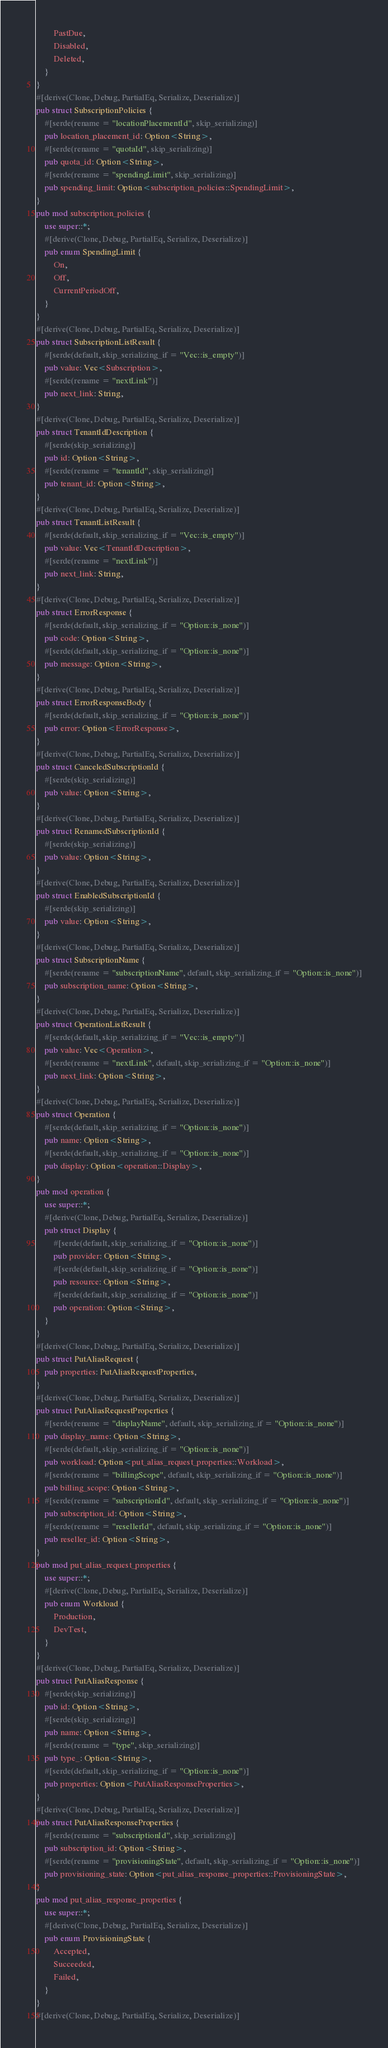<code> <loc_0><loc_0><loc_500><loc_500><_Rust_>        PastDue,
        Disabled,
        Deleted,
    }
}
#[derive(Clone, Debug, PartialEq, Serialize, Deserialize)]
pub struct SubscriptionPolicies {
    #[serde(rename = "locationPlacementId", skip_serializing)]
    pub location_placement_id: Option<String>,
    #[serde(rename = "quotaId", skip_serializing)]
    pub quota_id: Option<String>,
    #[serde(rename = "spendingLimit", skip_serializing)]
    pub spending_limit: Option<subscription_policies::SpendingLimit>,
}
pub mod subscription_policies {
    use super::*;
    #[derive(Clone, Debug, PartialEq, Serialize, Deserialize)]
    pub enum SpendingLimit {
        On,
        Off,
        CurrentPeriodOff,
    }
}
#[derive(Clone, Debug, PartialEq, Serialize, Deserialize)]
pub struct SubscriptionListResult {
    #[serde(default, skip_serializing_if = "Vec::is_empty")]
    pub value: Vec<Subscription>,
    #[serde(rename = "nextLink")]
    pub next_link: String,
}
#[derive(Clone, Debug, PartialEq, Serialize, Deserialize)]
pub struct TenantIdDescription {
    #[serde(skip_serializing)]
    pub id: Option<String>,
    #[serde(rename = "tenantId", skip_serializing)]
    pub tenant_id: Option<String>,
}
#[derive(Clone, Debug, PartialEq, Serialize, Deserialize)]
pub struct TenantListResult {
    #[serde(default, skip_serializing_if = "Vec::is_empty")]
    pub value: Vec<TenantIdDescription>,
    #[serde(rename = "nextLink")]
    pub next_link: String,
}
#[derive(Clone, Debug, PartialEq, Serialize, Deserialize)]
pub struct ErrorResponse {
    #[serde(default, skip_serializing_if = "Option::is_none")]
    pub code: Option<String>,
    #[serde(default, skip_serializing_if = "Option::is_none")]
    pub message: Option<String>,
}
#[derive(Clone, Debug, PartialEq, Serialize, Deserialize)]
pub struct ErrorResponseBody {
    #[serde(default, skip_serializing_if = "Option::is_none")]
    pub error: Option<ErrorResponse>,
}
#[derive(Clone, Debug, PartialEq, Serialize, Deserialize)]
pub struct CanceledSubscriptionId {
    #[serde(skip_serializing)]
    pub value: Option<String>,
}
#[derive(Clone, Debug, PartialEq, Serialize, Deserialize)]
pub struct RenamedSubscriptionId {
    #[serde(skip_serializing)]
    pub value: Option<String>,
}
#[derive(Clone, Debug, PartialEq, Serialize, Deserialize)]
pub struct EnabledSubscriptionId {
    #[serde(skip_serializing)]
    pub value: Option<String>,
}
#[derive(Clone, Debug, PartialEq, Serialize, Deserialize)]
pub struct SubscriptionName {
    #[serde(rename = "subscriptionName", default, skip_serializing_if = "Option::is_none")]
    pub subscription_name: Option<String>,
}
#[derive(Clone, Debug, PartialEq, Serialize, Deserialize)]
pub struct OperationListResult {
    #[serde(default, skip_serializing_if = "Vec::is_empty")]
    pub value: Vec<Operation>,
    #[serde(rename = "nextLink", default, skip_serializing_if = "Option::is_none")]
    pub next_link: Option<String>,
}
#[derive(Clone, Debug, PartialEq, Serialize, Deserialize)]
pub struct Operation {
    #[serde(default, skip_serializing_if = "Option::is_none")]
    pub name: Option<String>,
    #[serde(default, skip_serializing_if = "Option::is_none")]
    pub display: Option<operation::Display>,
}
pub mod operation {
    use super::*;
    #[derive(Clone, Debug, PartialEq, Serialize, Deserialize)]
    pub struct Display {
        #[serde(default, skip_serializing_if = "Option::is_none")]
        pub provider: Option<String>,
        #[serde(default, skip_serializing_if = "Option::is_none")]
        pub resource: Option<String>,
        #[serde(default, skip_serializing_if = "Option::is_none")]
        pub operation: Option<String>,
    }
}
#[derive(Clone, Debug, PartialEq, Serialize, Deserialize)]
pub struct PutAliasRequest {
    pub properties: PutAliasRequestProperties,
}
#[derive(Clone, Debug, PartialEq, Serialize, Deserialize)]
pub struct PutAliasRequestProperties {
    #[serde(rename = "displayName", default, skip_serializing_if = "Option::is_none")]
    pub display_name: Option<String>,
    #[serde(default, skip_serializing_if = "Option::is_none")]
    pub workload: Option<put_alias_request_properties::Workload>,
    #[serde(rename = "billingScope", default, skip_serializing_if = "Option::is_none")]
    pub billing_scope: Option<String>,
    #[serde(rename = "subscriptionId", default, skip_serializing_if = "Option::is_none")]
    pub subscription_id: Option<String>,
    #[serde(rename = "resellerId", default, skip_serializing_if = "Option::is_none")]
    pub reseller_id: Option<String>,
}
pub mod put_alias_request_properties {
    use super::*;
    #[derive(Clone, Debug, PartialEq, Serialize, Deserialize)]
    pub enum Workload {
        Production,
        DevTest,
    }
}
#[derive(Clone, Debug, PartialEq, Serialize, Deserialize)]
pub struct PutAliasResponse {
    #[serde(skip_serializing)]
    pub id: Option<String>,
    #[serde(skip_serializing)]
    pub name: Option<String>,
    #[serde(rename = "type", skip_serializing)]
    pub type_: Option<String>,
    #[serde(default, skip_serializing_if = "Option::is_none")]
    pub properties: Option<PutAliasResponseProperties>,
}
#[derive(Clone, Debug, PartialEq, Serialize, Deserialize)]
pub struct PutAliasResponseProperties {
    #[serde(rename = "subscriptionId", skip_serializing)]
    pub subscription_id: Option<String>,
    #[serde(rename = "provisioningState", default, skip_serializing_if = "Option::is_none")]
    pub provisioning_state: Option<put_alias_response_properties::ProvisioningState>,
}
pub mod put_alias_response_properties {
    use super::*;
    #[derive(Clone, Debug, PartialEq, Serialize, Deserialize)]
    pub enum ProvisioningState {
        Accepted,
        Succeeded,
        Failed,
    }
}
#[derive(Clone, Debug, PartialEq, Serialize, Deserialize)]</code> 